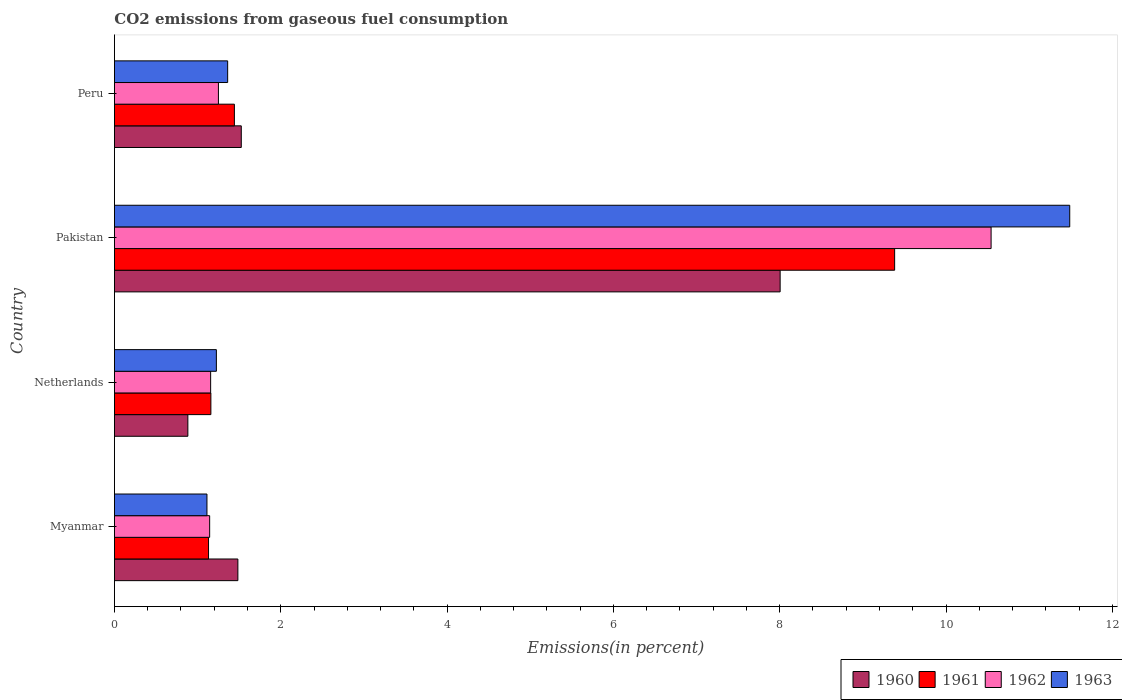Are the number of bars per tick equal to the number of legend labels?
Provide a succinct answer. Yes. Are the number of bars on each tick of the Y-axis equal?
Your answer should be very brief. Yes. How many bars are there on the 1st tick from the top?
Your answer should be compact. 4. How many bars are there on the 4th tick from the bottom?
Your response must be concise. 4. What is the label of the 1st group of bars from the top?
Give a very brief answer. Peru. In how many cases, is the number of bars for a given country not equal to the number of legend labels?
Offer a very short reply. 0. What is the total CO2 emitted in 1962 in Pakistan?
Provide a succinct answer. 10.54. Across all countries, what is the maximum total CO2 emitted in 1963?
Offer a terse response. 11.49. Across all countries, what is the minimum total CO2 emitted in 1962?
Ensure brevity in your answer.  1.15. In which country was the total CO2 emitted in 1961 maximum?
Make the answer very short. Pakistan. In which country was the total CO2 emitted in 1960 minimum?
Keep it short and to the point. Netherlands. What is the total total CO2 emitted in 1961 in the graph?
Your response must be concise. 13.12. What is the difference between the total CO2 emitted in 1961 in Pakistan and that in Peru?
Your response must be concise. 7.94. What is the difference between the total CO2 emitted in 1962 in Myanmar and the total CO2 emitted in 1960 in Pakistan?
Keep it short and to the point. -6.86. What is the average total CO2 emitted in 1962 per country?
Ensure brevity in your answer.  3.52. What is the difference between the total CO2 emitted in 1963 and total CO2 emitted in 1962 in Pakistan?
Your response must be concise. 0.95. In how many countries, is the total CO2 emitted in 1963 greater than 9.6 %?
Provide a succinct answer. 1. What is the ratio of the total CO2 emitted in 1963 in Netherlands to that in Peru?
Make the answer very short. 0.9. Is the total CO2 emitted in 1960 in Myanmar less than that in Pakistan?
Provide a succinct answer. Yes. What is the difference between the highest and the second highest total CO2 emitted in 1963?
Offer a very short reply. 10.13. What is the difference between the highest and the lowest total CO2 emitted in 1960?
Ensure brevity in your answer.  7.12. In how many countries, is the total CO2 emitted in 1961 greater than the average total CO2 emitted in 1961 taken over all countries?
Provide a succinct answer. 1. Is the sum of the total CO2 emitted in 1961 in Netherlands and Peru greater than the maximum total CO2 emitted in 1960 across all countries?
Offer a terse response. No. Is it the case that in every country, the sum of the total CO2 emitted in 1962 and total CO2 emitted in 1963 is greater than the sum of total CO2 emitted in 1960 and total CO2 emitted in 1961?
Provide a succinct answer. No. What does the 2nd bar from the top in Pakistan represents?
Give a very brief answer. 1962. What does the 1st bar from the bottom in Peru represents?
Make the answer very short. 1960. Is it the case that in every country, the sum of the total CO2 emitted in 1960 and total CO2 emitted in 1962 is greater than the total CO2 emitted in 1963?
Offer a very short reply. Yes. How many bars are there?
Your response must be concise. 16. How many countries are there in the graph?
Offer a very short reply. 4. What is the difference between two consecutive major ticks on the X-axis?
Your response must be concise. 2. How are the legend labels stacked?
Provide a succinct answer. Horizontal. What is the title of the graph?
Offer a terse response. CO2 emissions from gaseous fuel consumption. What is the label or title of the X-axis?
Make the answer very short. Emissions(in percent). What is the label or title of the Y-axis?
Provide a succinct answer. Country. What is the Emissions(in percent) in 1960 in Myanmar?
Your answer should be very brief. 1.48. What is the Emissions(in percent) of 1961 in Myanmar?
Your answer should be compact. 1.13. What is the Emissions(in percent) of 1962 in Myanmar?
Offer a terse response. 1.15. What is the Emissions(in percent) of 1963 in Myanmar?
Give a very brief answer. 1.11. What is the Emissions(in percent) in 1960 in Netherlands?
Ensure brevity in your answer.  0.88. What is the Emissions(in percent) in 1961 in Netherlands?
Provide a succinct answer. 1.16. What is the Emissions(in percent) in 1962 in Netherlands?
Provide a short and direct response. 1.16. What is the Emissions(in percent) in 1963 in Netherlands?
Offer a very short reply. 1.23. What is the Emissions(in percent) in 1960 in Pakistan?
Offer a terse response. 8.01. What is the Emissions(in percent) in 1961 in Pakistan?
Provide a short and direct response. 9.38. What is the Emissions(in percent) in 1962 in Pakistan?
Make the answer very short. 10.54. What is the Emissions(in percent) in 1963 in Pakistan?
Provide a short and direct response. 11.49. What is the Emissions(in percent) in 1960 in Peru?
Provide a short and direct response. 1.53. What is the Emissions(in percent) in 1961 in Peru?
Your answer should be compact. 1.44. What is the Emissions(in percent) of 1962 in Peru?
Provide a short and direct response. 1.25. What is the Emissions(in percent) in 1963 in Peru?
Your answer should be compact. 1.36. Across all countries, what is the maximum Emissions(in percent) of 1960?
Provide a short and direct response. 8.01. Across all countries, what is the maximum Emissions(in percent) of 1961?
Your answer should be very brief. 9.38. Across all countries, what is the maximum Emissions(in percent) in 1962?
Your response must be concise. 10.54. Across all countries, what is the maximum Emissions(in percent) of 1963?
Provide a succinct answer. 11.49. Across all countries, what is the minimum Emissions(in percent) of 1960?
Keep it short and to the point. 0.88. Across all countries, what is the minimum Emissions(in percent) in 1961?
Give a very brief answer. 1.13. Across all countries, what is the minimum Emissions(in percent) of 1962?
Make the answer very short. 1.15. Across all countries, what is the minimum Emissions(in percent) of 1963?
Provide a succinct answer. 1.11. What is the total Emissions(in percent) in 1960 in the graph?
Provide a short and direct response. 11.9. What is the total Emissions(in percent) in 1961 in the graph?
Offer a very short reply. 13.12. What is the total Emissions(in percent) of 1962 in the graph?
Make the answer very short. 14.09. What is the total Emissions(in percent) in 1963 in the graph?
Offer a very short reply. 15.19. What is the difference between the Emissions(in percent) in 1960 in Myanmar and that in Netherlands?
Give a very brief answer. 0.6. What is the difference between the Emissions(in percent) of 1961 in Myanmar and that in Netherlands?
Your response must be concise. -0.03. What is the difference between the Emissions(in percent) in 1962 in Myanmar and that in Netherlands?
Make the answer very short. -0.01. What is the difference between the Emissions(in percent) of 1963 in Myanmar and that in Netherlands?
Provide a short and direct response. -0.11. What is the difference between the Emissions(in percent) in 1960 in Myanmar and that in Pakistan?
Provide a short and direct response. -6.52. What is the difference between the Emissions(in percent) of 1961 in Myanmar and that in Pakistan?
Your answer should be compact. -8.25. What is the difference between the Emissions(in percent) of 1962 in Myanmar and that in Pakistan?
Offer a very short reply. -9.4. What is the difference between the Emissions(in percent) of 1963 in Myanmar and that in Pakistan?
Your response must be concise. -10.37. What is the difference between the Emissions(in percent) in 1960 in Myanmar and that in Peru?
Your answer should be compact. -0.04. What is the difference between the Emissions(in percent) of 1961 in Myanmar and that in Peru?
Make the answer very short. -0.31. What is the difference between the Emissions(in percent) of 1962 in Myanmar and that in Peru?
Ensure brevity in your answer.  -0.11. What is the difference between the Emissions(in percent) of 1963 in Myanmar and that in Peru?
Provide a short and direct response. -0.25. What is the difference between the Emissions(in percent) in 1960 in Netherlands and that in Pakistan?
Keep it short and to the point. -7.12. What is the difference between the Emissions(in percent) of 1961 in Netherlands and that in Pakistan?
Your response must be concise. -8.22. What is the difference between the Emissions(in percent) of 1962 in Netherlands and that in Pakistan?
Offer a very short reply. -9.38. What is the difference between the Emissions(in percent) in 1963 in Netherlands and that in Pakistan?
Provide a succinct answer. -10.26. What is the difference between the Emissions(in percent) in 1960 in Netherlands and that in Peru?
Give a very brief answer. -0.64. What is the difference between the Emissions(in percent) in 1961 in Netherlands and that in Peru?
Offer a very short reply. -0.28. What is the difference between the Emissions(in percent) of 1962 in Netherlands and that in Peru?
Provide a short and direct response. -0.09. What is the difference between the Emissions(in percent) of 1963 in Netherlands and that in Peru?
Give a very brief answer. -0.14. What is the difference between the Emissions(in percent) of 1960 in Pakistan and that in Peru?
Provide a succinct answer. 6.48. What is the difference between the Emissions(in percent) in 1961 in Pakistan and that in Peru?
Make the answer very short. 7.94. What is the difference between the Emissions(in percent) in 1962 in Pakistan and that in Peru?
Offer a very short reply. 9.29. What is the difference between the Emissions(in percent) of 1963 in Pakistan and that in Peru?
Make the answer very short. 10.13. What is the difference between the Emissions(in percent) in 1960 in Myanmar and the Emissions(in percent) in 1961 in Netherlands?
Provide a short and direct response. 0.32. What is the difference between the Emissions(in percent) in 1960 in Myanmar and the Emissions(in percent) in 1962 in Netherlands?
Your answer should be compact. 0.33. What is the difference between the Emissions(in percent) of 1960 in Myanmar and the Emissions(in percent) of 1963 in Netherlands?
Offer a terse response. 0.26. What is the difference between the Emissions(in percent) of 1961 in Myanmar and the Emissions(in percent) of 1962 in Netherlands?
Your response must be concise. -0.03. What is the difference between the Emissions(in percent) in 1961 in Myanmar and the Emissions(in percent) in 1963 in Netherlands?
Your answer should be very brief. -0.09. What is the difference between the Emissions(in percent) in 1962 in Myanmar and the Emissions(in percent) in 1963 in Netherlands?
Provide a succinct answer. -0.08. What is the difference between the Emissions(in percent) of 1960 in Myanmar and the Emissions(in percent) of 1961 in Pakistan?
Ensure brevity in your answer.  -7.9. What is the difference between the Emissions(in percent) of 1960 in Myanmar and the Emissions(in percent) of 1962 in Pakistan?
Provide a succinct answer. -9.06. What is the difference between the Emissions(in percent) of 1960 in Myanmar and the Emissions(in percent) of 1963 in Pakistan?
Offer a terse response. -10. What is the difference between the Emissions(in percent) of 1961 in Myanmar and the Emissions(in percent) of 1962 in Pakistan?
Provide a short and direct response. -9.41. What is the difference between the Emissions(in percent) of 1961 in Myanmar and the Emissions(in percent) of 1963 in Pakistan?
Provide a succinct answer. -10.36. What is the difference between the Emissions(in percent) in 1962 in Myanmar and the Emissions(in percent) in 1963 in Pakistan?
Offer a terse response. -10.34. What is the difference between the Emissions(in percent) of 1960 in Myanmar and the Emissions(in percent) of 1961 in Peru?
Offer a very short reply. 0.04. What is the difference between the Emissions(in percent) in 1960 in Myanmar and the Emissions(in percent) in 1962 in Peru?
Provide a succinct answer. 0.23. What is the difference between the Emissions(in percent) in 1960 in Myanmar and the Emissions(in percent) in 1963 in Peru?
Your answer should be compact. 0.12. What is the difference between the Emissions(in percent) of 1961 in Myanmar and the Emissions(in percent) of 1962 in Peru?
Your answer should be compact. -0.12. What is the difference between the Emissions(in percent) of 1961 in Myanmar and the Emissions(in percent) of 1963 in Peru?
Your answer should be compact. -0.23. What is the difference between the Emissions(in percent) of 1962 in Myanmar and the Emissions(in percent) of 1963 in Peru?
Provide a short and direct response. -0.22. What is the difference between the Emissions(in percent) of 1960 in Netherlands and the Emissions(in percent) of 1961 in Pakistan?
Provide a succinct answer. -8.5. What is the difference between the Emissions(in percent) of 1960 in Netherlands and the Emissions(in percent) of 1962 in Pakistan?
Your answer should be compact. -9.66. What is the difference between the Emissions(in percent) in 1960 in Netherlands and the Emissions(in percent) in 1963 in Pakistan?
Your answer should be very brief. -10.6. What is the difference between the Emissions(in percent) in 1961 in Netherlands and the Emissions(in percent) in 1962 in Pakistan?
Provide a succinct answer. -9.38. What is the difference between the Emissions(in percent) in 1961 in Netherlands and the Emissions(in percent) in 1963 in Pakistan?
Give a very brief answer. -10.33. What is the difference between the Emissions(in percent) in 1962 in Netherlands and the Emissions(in percent) in 1963 in Pakistan?
Provide a succinct answer. -10.33. What is the difference between the Emissions(in percent) in 1960 in Netherlands and the Emissions(in percent) in 1961 in Peru?
Provide a succinct answer. -0.56. What is the difference between the Emissions(in percent) of 1960 in Netherlands and the Emissions(in percent) of 1962 in Peru?
Ensure brevity in your answer.  -0.37. What is the difference between the Emissions(in percent) of 1960 in Netherlands and the Emissions(in percent) of 1963 in Peru?
Your answer should be very brief. -0.48. What is the difference between the Emissions(in percent) of 1961 in Netherlands and the Emissions(in percent) of 1962 in Peru?
Provide a succinct answer. -0.09. What is the difference between the Emissions(in percent) of 1961 in Netherlands and the Emissions(in percent) of 1963 in Peru?
Keep it short and to the point. -0.2. What is the difference between the Emissions(in percent) in 1962 in Netherlands and the Emissions(in percent) in 1963 in Peru?
Offer a terse response. -0.2. What is the difference between the Emissions(in percent) of 1960 in Pakistan and the Emissions(in percent) of 1961 in Peru?
Keep it short and to the point. 6.56. What is the difference between the Emissions(in percent) of 1960 in Pakistan and the Emissions(in percent) of 1962 in Peru?
Your response must be concise. 6.75. What is the difference between the Emissions(in percent) of 1960 in Pakistan and the Emissions(in percent) of 1963 in Peru?
Provide a succinct answer. 6.64. What is the difference between the Emissions(in percent) in 1961 in Pakistan and the Emissions(in percent) in 1962 in Peru?
Give a very brief answer. 8.13. What is the difference between the Emissions(in percent) in 1961 in Pakistan and the Emissions(in percent) in 1963 in Peru?
Your answer should be very brief. 8.02. What is the difference between the Emissions(in percent) in 1962 in Pakistan and the Emissions(in percent) in 1963 in Peru?
Give a very brief answer. 9.18. What is the average Emissions(in percent) in 1960 per country?
Provide a succinct answer. 2.97. What is the average Emissions(in percent) of 1961 per country?
Make the answer very short. 3.28. What is the average Emissions(in percent) in 1962 per country?
Give a very brief answer. 3.52. What is the average Emissions(in percent) in 1963 per country?
Give a very brief answer. 3.8. What is the difference between the Emissions(in percent) in 1960 and Emissions(in percent) in 1961 in Myanmar?
Your response must be concise. 0.35. What is the difference between the Emissions(in percent) of 1960 and Emissions(in percent) of 1962 in Myanmar?
Provide a short and direct response. 0.34. What is the difference between the Emissions(in percent) of 1960 and Emissions(in percent) of 1963 in Myanmar?
Your answer should be compact. 0.37. What is the difference between the Emissions(in percent) of 1961 and Emissions(in percent) of 1962 in Myanmar?
Your response must be concise. -0.01. What is the difference between the Emissions(in percent) of 1961 and Emissions(in percent) of 1963 in Myanmar?
Provide a short and direct response. 0.02. What is the difference between the Emissions(in percent) in 1962 and Emissions(in percent) in 1963 in Myanmar?
Make the answer very short. 0.03. What is the difference between the Emissions(in percent) in 1960 and Emissions(in percent) in 1961 in Netherlands?
Your answer should be very brief. -0.28. What is the difference between the Emissions(in percent) in 1960 and Emissions(in percent) in 1962 in Netherlands?
Provide a succinct answer. -0.27. What is the difference between the Emissions(in percent) of 1960 and Emissions(in percent) of 1963 in Netherlands?
Provide a succinct answer. -0.34. What is the difference between the Emissions(in percent) in 1961 and Emissions(in percent) in 1962 in Netherlands?
Provide a short and direct response. 0. What is the difference between the Emissions(in percent) in 1961 and Emissions(in percent) in 1963 in Netherlands?
Offer a terse response. -0.07. What is the difference between the Emissions(in percent) in 1962 and Emissions(in percent) in 1963 in Netherlands?
Offer a terse response. -0.07. What is the difference between the Emissions(in percent) in 1960 and Emissions(in percent) in 1961 in Pakistan?
Offer a very short reply. -1.38. What is the difference between the Emissions(in percent) in 1960 and Emissions(in percent) in 1962 in Pakistan?
Ensure brevity in your answer.  -2.54. What is the difference between the Emissions(in percent) in 1960 and Emissions(in percent) in 1963 in Pakistan?
Give a very brief answer. -3.48. What is the difference between the Emissions(in percent) in 1961 and Emissions(in percent) in 1962 in Pakistan?
Provide a short and direct response. -1.16. What is the difference between the Emissions(in percent) of 1961 and Emissions(in percent) of 1963 in Pakistan?
Your answer should be very brief. -2.11. What is the difference between the Emissions(in percent) in 1962 and Emissions(in percent) in 1963 in Pakistan?
Provide a short and direct response. -0.95. What is the difference between the Emissions(in percent) of 1960 and Emissions(in percent) of 1961 in Peru?
Provide a succinct answer. 0.08. What is the difference between the Emissions(in percent) of 1960 and Emissions(in percent) of 1962 in Peru?
Your response must be concise. 0.27. What is the difference between the Emissions(in percent) of 1960 and Emissions(in percent) of 1963 in Peru?
Offer a very short reply. 0.16. What is the difference between the Emissions(in percent) of 1961 and Emissions(in percent) of 1962 in Peru?
Make the answer very short. 0.19. What is the difference between the Emissions(in percent) in 1961 and Emissions(in percent) in 1963 in Peru?
Your answer should be very brief. 0.08. What is the difference between the Emissions(in percent) in 1962 and Emissions(in percent) in 1963 in Peru?
Provide a succinct answer. -0.11. What is the ratio of the Emissions(in percent) in 1960 in Myanmar to that in Netherlands?
Offer a very short reply. 1.68. What is the ratio of the Emissions(in percent) of 1961 in Myanmar to that in Netherlands?
Your answer should be very brief. 0.98. What is the ratio of the Emissions(in percent) of 1962 in Myanmar to that in Netherlands?
Provide a short and direct response. 0.99. What is the ratio of the Emissions(in percent) of 1963 in Myanmar to that in Netherlands?
Give a very brief answer. 0.91. What is the ratio of the Emissions(in percent) in 1960 in Myanmar to that in Pakistan?
Provide a short and direct response. 0.19. What is the ratio of the Emissions(in percent) of 1961 in Myanmar to that in Pakistan?
Offer a terse response. 0.12. What is the ratio of the Emissions(in percent) of 1962 in Myanmar to that in Pakistan?
Provide a short and direct response. 0.11. What is the ratio of the Emissions(in percent) in 1963 in Myanmar to that in Pakistan?
Give a very brief answer. 0.1. What is the ratio of the Emissions(in percent) of 1960 in Myanmar to that in Peru?
Provide a succinct answer. 0.97. What is the ratio of the Emissions(in percent) in 1961 in Myanmar to that in Peru?
Offer a terse response. 0.78. What is the ratio of the Emissions(in percent) of 1962 in Myanmar to that in Peru?
Give a very brief answer. 0.92. What is the ratio of the Emissions(in percent) in 1963 in Myanmar to that in Peru?
Ensure brevity in your answer.  0.82. What is the ratio of the Emissions(in percent) in 1960 in Netherlands to that in Pakistan?
Provide a succinct answer. 0.11. What is the ratio of the Emissions(in percent) of 1961 in Netherlands to that in Pakistan?
Offer a very short reply. 0.12. What is the ratio of the Emissions(in percent) of 1962 in Netherlands to that in Pakistan?
Your answer should be compact. 0.11. What is the ratio of the Emissions(in percent) of 1963 in Netherlands to that in Pakistan?
Your answer should be very brief. 0.11. What is the ratio of the Emissions(in percent) of 1960 in Netherlands to that in Peru?
Give a very brief answer. 0.58. What is the ratio of the Emissions(in percent) of 1961 in Netherlands to that in Peru?
Provide a succinct answer. 0.8. What is the ratio of the Emissions(in percent) of 1962 in Netherlands to that in Peru?
Your answer should be very brief. 0.93. What is the ratio of the Emissions(in percent) of 1963 in Netherlands to that in Peru?
Ensure brevity in your answer.  0.9. What is the ratio of the Emissions(in percent) in 1960 in Pakistan to that in Peru?
Provide a short and direct response. 5.25. What is the ratio of the Emissions(in percent) of 1961 in Pakistan to that in Peru?
Give a very brief answer. 6.5. What is the ratio of the Emissions(in percent) of 1962 in Pakistan to that in Peru?
Offer a very short reply. 8.43. What is the ratio of the Emissions(in percent) in 1963 in Pakistan to that in Peru?
Keep it short and to the point. 8.44. What is the difference between the highest and the second highest Emissions(in percent) of 1960?
Keep it short and to the point. 6.48. What is the difference between the highest and the second highest Emissions(in percent) in 1961?
Your answer should be compact. 7.94. What is the difference between the highest and the second highest Emissions(in percent) in 1962?
Ensure brevity in your answer.  9.29. What is the difference between the highest and the second highest Emissions(in percent) of 1963?
Your answer should be very brief. 10.13. What is the difference between the highest and the lowest Emissions(in percent) of 1960?
Offer a very short reply. 7.12. What is the difference between the highest and the lowest Emissions(in percent) of 1961?
Your answer should be very brief. 8.25. What is the difference between the highest and the lowest Emissions(in percent) of 1962?
Your answer should be very brief. 9.4. What is the difference between the highest and the lowest Emissions(in percent) in 1963?
Offer a very short reply. 10.37. 